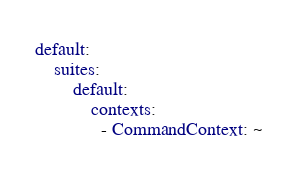<code> <loc_0><loc_0><loc_500><loc_500><_YAML_>default:
    suites:
        default:
            contexts:
              - CommandContext: ~</code> 